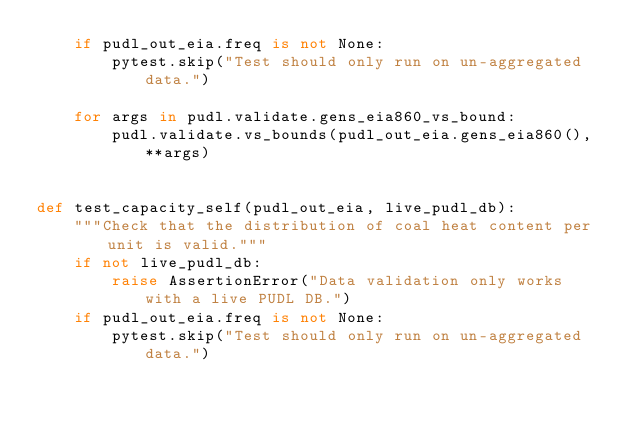<code> <loc_0><loc_0><loc_500><loc_500><_Python_>    if pudl_out_eia.freq is not None:
        pytest.skip("Test should only run on un-aggregated data.")

    for args in pudl.validate.gens_eia860_vs_bound:
        pudl.validate.vs_bounds(pudl_out_eia.gens_eia860(), **args)


def test_capacity_self(pudl_out_eia, live_pudl_db):
    """Check that the distribution of coal heat content per unit is valid."""
    if not live_pudl_db:
        raise AssertionError("Data validation only works with a live PUDL DB.")
    if pudl_out_eia.freq is not None:
        pytest.skip("Test should only run on un-aggregated data.")
</code> 